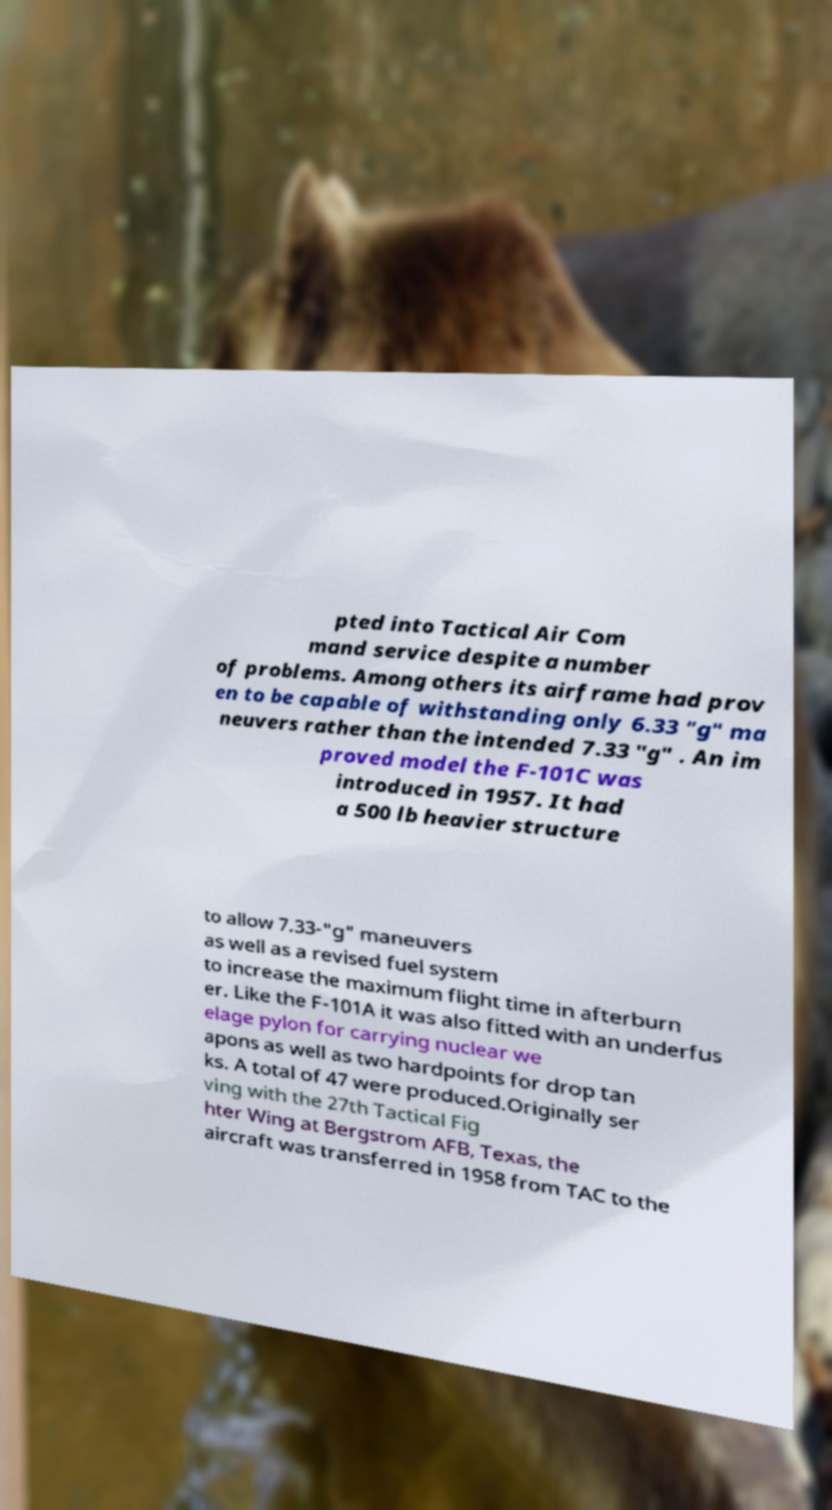Please read and relay the text visible in this image. What does it say? pted into Tactical Air Com mand service despite a number of problems. Among others its airframe had prov en to be capable of withstanding only 6.33 "g" ma neuvers rather than the intended 7.33 "g" . An im proved model the F-101C was introduced in 1957. It had a 500 lb heavier structure to allow 7.33-"g" maneuvers as well as a revised fuel system to increase the maximum flight time in afterburn er. Like the F-101A it was also fitted with an underfus elage pylon for carrying nuclear we apons as well as two hardpoints for drop tan ks. A total of 47 were produced.Originally ser ving with the 27th Tactical Fig hter Wing at Bergstrom AFB, Texas, the aircraft was transferred in 1958 from TAC to the 